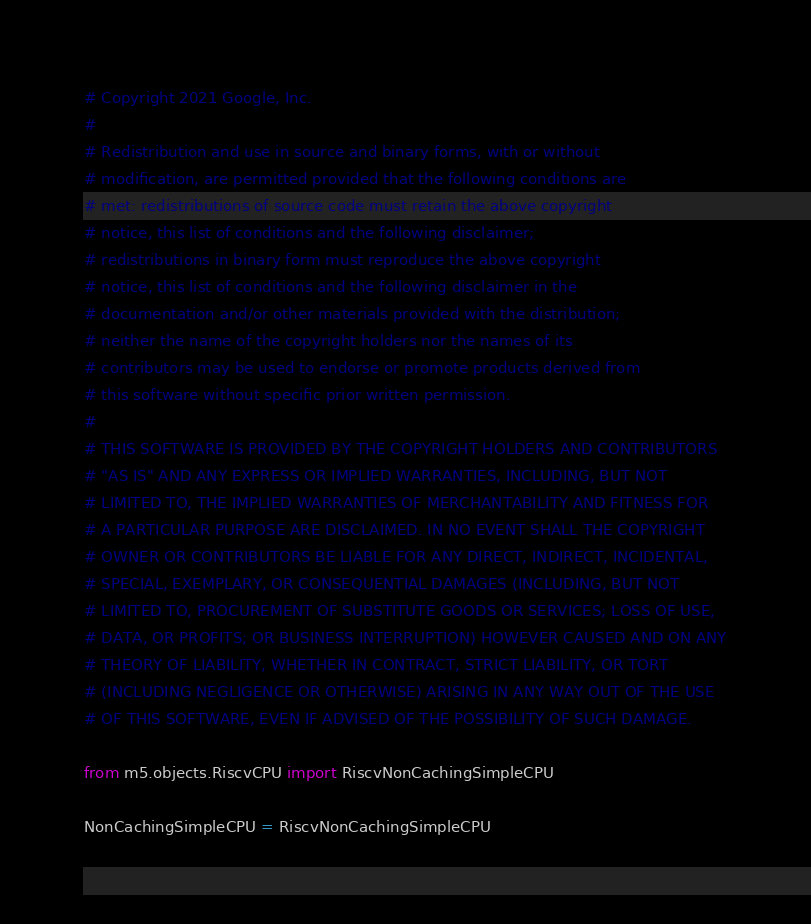Convert code to text. <code><loc_0><loc_0><loc_500><loc_500><_Python_># Copyright 2021 Google, Inc.
#
# Redistribution and use in source and binary forms, with or without
# modification, are permitted provided that the following conditions are
# met: redistributions of source code must retain the above copyright
# notice, this list of conditions and the following disclaimer;
# redistributions in binary form must reproduce the above copyright
# notice, this list of conditions and the following disclaimer in the
# documentation and/or other materials provided with the distribution;
# neither the name of the copyright holders nor the names of its
# contributors may be used to endorse or promote products derived from
# this software without specific prior written permission.
#
# THIS SOFTWARE IS PROVIDED BY THE COPYRIGHT HOLDERS AND CONTRIBUTORS
# "AS IS" AND ANY EXPRESS OR IMPLIED WARRANTIES, INCLUDING, BUT NOT
# LIMITED TO, THE IMPLIED WARRANTIES OF MERCHANTABILITY AND FITNESS FOR
# A PARTICULAR PURPOSE ARE DISCLAIMED. IN NO EVENT SHALL THE COPYRIGHT
# OWNER OR CONTRIBUTORS BE LIABLE FOR ANY DIRECT, INDIRECT, INCIDENTAL,
# SPECIAL, EXEMPLARY, OR CONSEQUENTIAL DAMAGES (INCLUDING, BUT NOT
# LIMITED TO, PROCUREMENT OF SUBSTITUTE GOODS OR SERVICES; LOSS OF USE,
# DATA, OR PROFITS; OR BUSINESS INTERRUPTION) HOWEVER CAUSED AND ON ANY
# THEORY OF LIABILITY, WHETHER IN CONTRACT, STRICT LIABILITY, OR TORT
# (INCLUDING NEGLIGENCE OR OTHERWISE) ARISING IN ANY WAY OUT OF THE USE
# OF THIS SOFTWARE, EVEN IF ADVISED OF THE POSSIBILITY OF SUCH DAMAGE.

from m5.objects.RiscvCPU import RiscvNonCachingSimpleCPU

NonCachingSimpleCPU = RiscvNonCachingSimpleCPU
</code> 